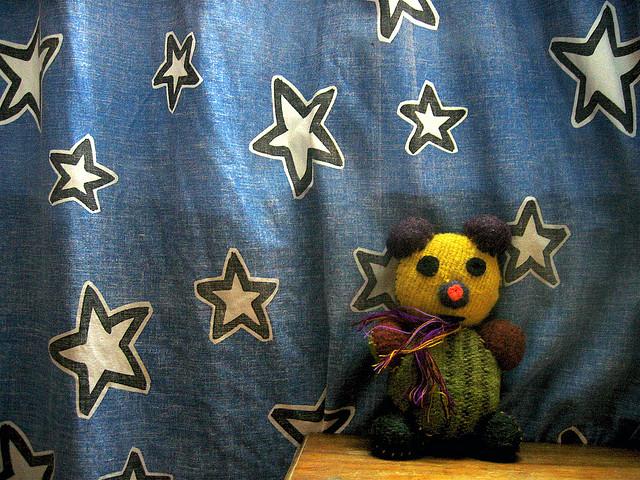What pattern is the background?
Be succinct. Stars. Is this object for sale?
Answer briefly. No. How is the bear made?
Quick response, please. Handmade. 